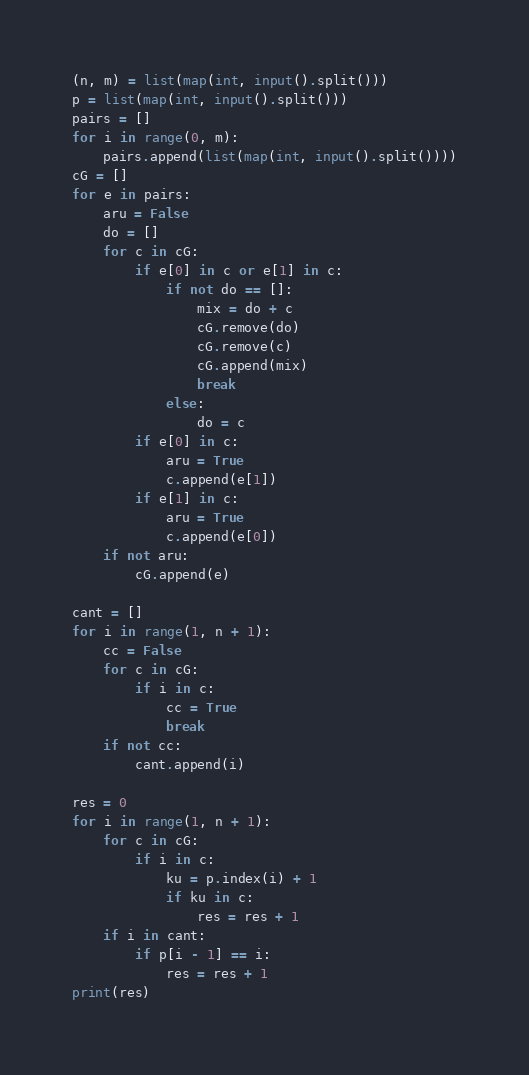<code> <loc_0><loc_0><loc_500><loc_500><_Python_>(n, m) = list(map(int, input().split()))
p = list(map(int, input().split()))
pairs = []
for i in range(0, m):
    pairs.append(list(map(int, input().split())))
cG = []
for e in pairs:
    aru = False
    do = []
    for c in cG:
        if e[0] in c or e[1] in c:
            if not do == []:
                mix = do + c
                cG.remove(do)
                cG.remove(c)
                cG.append(mix)
                break
            else:
                do = c
        if e[0] in c:
            aru = True
            c.append(e[1])
        if e[1] in c:
            aru = True
            c.append(e[0])
    if not aru:
        cG.append(e)

cant = []
for i in range(1, n + 1):
    cc = False
    for c in cG:
        if i in c:
            cc = True
            break
    if not cc:
        cant.append(i)

res = 0
for i in range(1, n + 1):
    for c in cG:
        if i in c:
            ku = p.index(i) + 1
            if ku in c:
                res = res + 1
    if i in cant:
        if p[i - 1] == i:
            res = res + 1
print(res)
</code> 